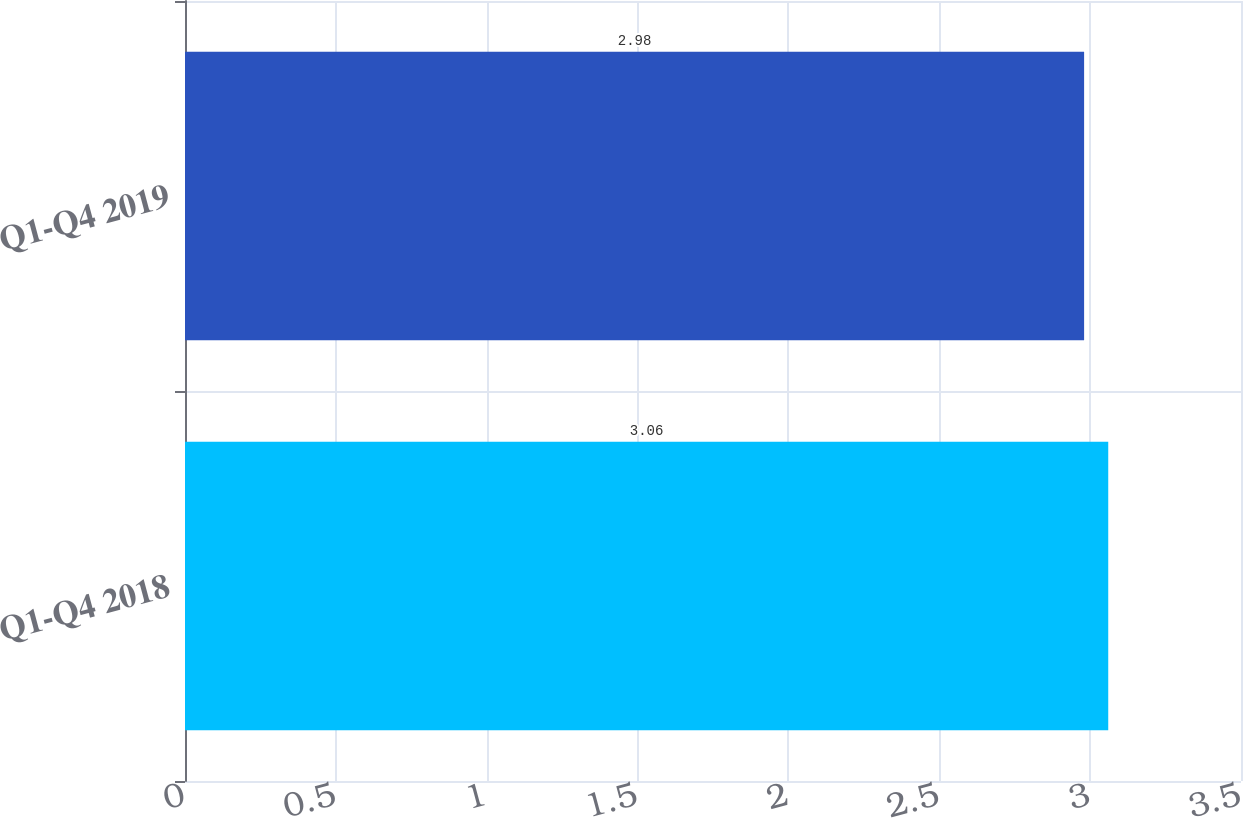Convert chart to OTSL. <chart><loc_0><loc_0><loc_500><loc_500><bar_chart><fcel>Q1-Q4 2018<fcel>Q1-Q4 2019<nl><fcel>3.06<fcel>2.98<nl></chart> 